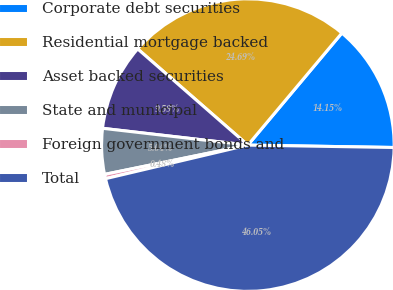Convert chart to OTSL. <chart><loc_0><loc_0><loc_500><loc_500><pie_chart><fcel>Corporate debt securities<fcel>Residential mortgage backed<fcel>Asset backed securities<fcel>State and municipal<fcel>Foreign government bonds and<fcel>Total<nl><fcel>14.15%<fcel>24.69%<fcel>9.59%<fcel>5.04%<fcel>0.48%<fcel>46.05%<nl></chart> 